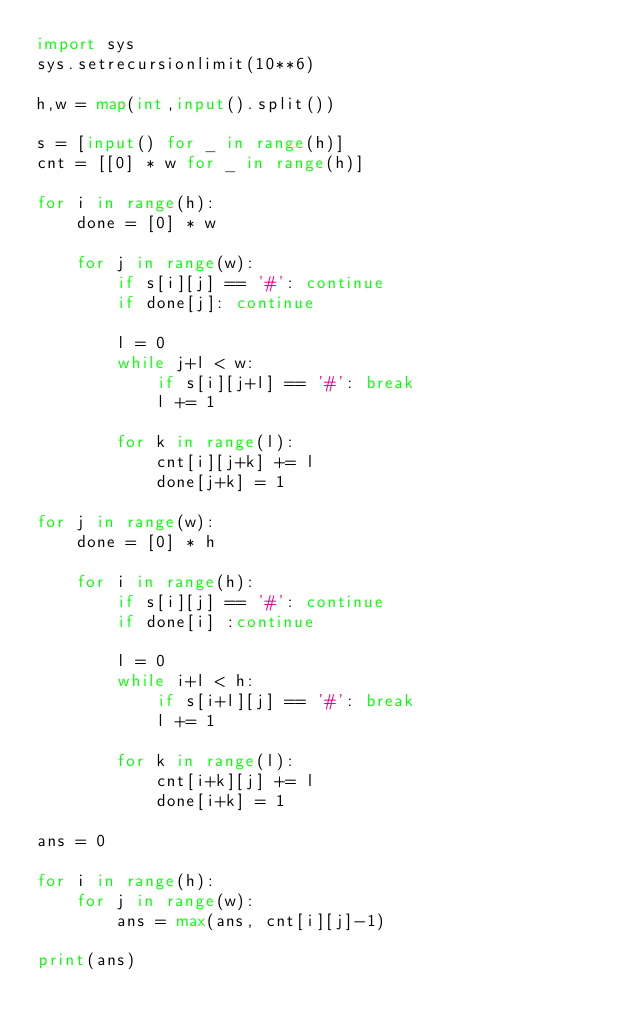Convert code to text. <code><loc_0><loc_0><loc_500><loc_500><_Python_>import sys
sys.setrecursionlimit(10**6)

h,w = map(int,input().split())

s = [input() for _ in range(h)]
cnt = [[0] * w for _ in range(h)]

for i in range(h):
    done = [0] * w

    for j in range(w):
        if s[i][j] == '#': continue
        if done[j]: continue

        l = 0
        while j+l < w:
            if s[i][j+l] == '#': break
            l += 1

        for k in range(l):
            cnt[i][j+k] += l
            done[j+k] = 1

for j in range(w):
    done = [0] * h

    for i in range(h):
        if s[i][j] == '#': continue
        if done[i] :continue

        l = 0
        while i+l < h:
            if s[i+l][j] == '#': break
            l += 1

        for k in range(l):
            cnt[i+k][j] += l
            done[i+k] = 1

ans = 0

for i in range(h):
    for j in range(w):
        ans = max(ans, cnt[i][j]-1)

print(ans)</code> 